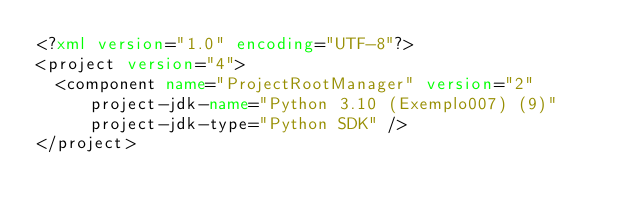<code> <loc_0><loc_0><loc_500><loc_500><_XML_><?xml version="1.0" encoding="UTF-8"?>
<project version="4">
  <component name="ProjectRootManager" version="2" project-jdk-name="Python 3.10 (Exemplo007) (9)" project-jdk-type="Python SDK" />
</project></code> 